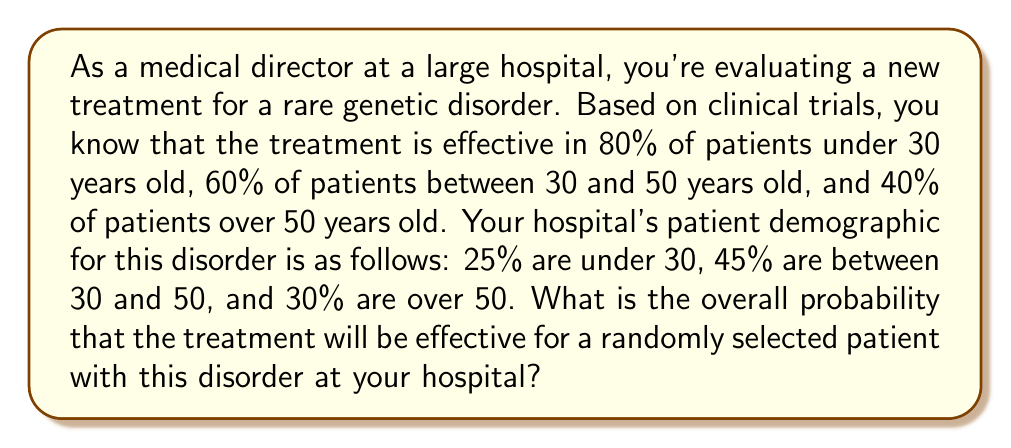Can you solve this math problem? To solve this problem, we'll use the law of total probability. Let's break it down step by step:

1) Let's define our events:
   A = treatment is effective
   B1 = patient is under 30
   B2 = patient is between 30 and 50
   B3 = patient is over 50

2) We're given the following probabilities:
   P(A|B1) = 0.80
   P(A|B2) = 0.60
   P(A|B3) = 0.40
   P(B1) = 0.25
   P(B2) = 0.45
   P(B3) = 0.30

3) The law of total probability states:
   $$P(A) = P(A|B1)P(B1) + P(A|B2)P(B2) + P(A|B3)P(B3)$$

4) Let's substitute our values:
   $$P(A) = (0.80)(0.25) + (0.60)(0.45) + (0.40)(0.30)$$

5) Now let's calculate:
   $$P(A) = 0.20 + 0.27 + 0.12 = 0.59$$

Therefore, the overall probability that the treatment will be effective for a randomly selected patient is 0.59 or 59%.
Answer: The overall probability that the treatment will be effective for a randomly selected patient is 0.59 or 59%. 